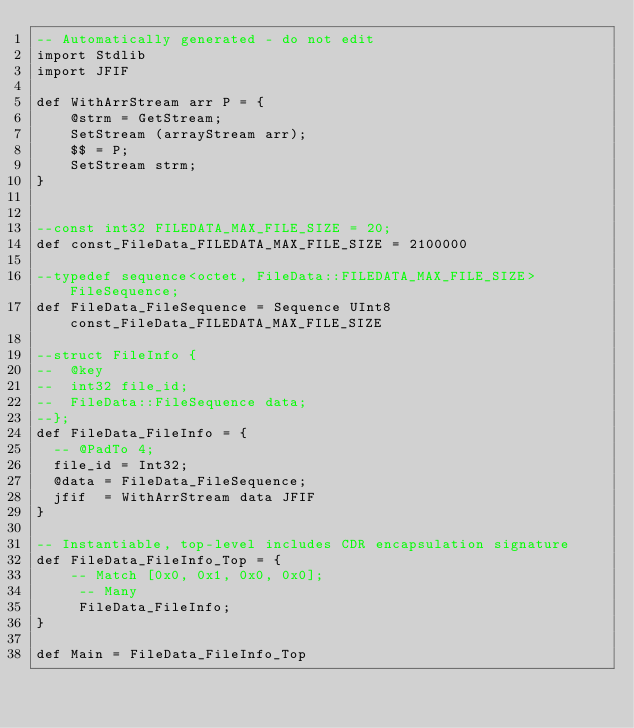Convert code to text. <code><loc_0><loc_0><loc_500><loc_500><_SQL_>-- Automatically generated - do not edit
import Stdlib
import JFIF

def WithArrStream arr P = {
    @strm = GetStream;
    SetStream (arrayStream arr);
    $$ = P;
    SetStream strm;
}    
    

--const int32 FILEDATA_MAX_FILE_SIZE = 20;
def const_FileData_FILEDATA_MAX_FILE_SIZE = 2100000

--typedef sequence<octet, FileData::FILEDATA_MAX_FILE_SIZE> FileSequence;
def FileData_FileSequence = Sequence UInt8 const_FileData_FILEDATA_MAX_FILE_SIZE

--struct FileInfo {
--  @key
--  int32 file_id;
--  FileData::FileSequence data;
--};
def FileData_FileInfo = {
  -- @PadTo 4;
  file_id = Int32;
  @data = FileData_FileSequence;
  jfif  = WithArrStream data JFIF
}

-- Instantiable, top-level includes CDR encapsulation signature
def FileData_FileInfo_Top = {
    -- Match [0x0, 0x1, 0x0, 0x0];
     -- Many
     FileData_FileInfo;
}

def Main = FileData_FileInfo_Top 



 
</code> 